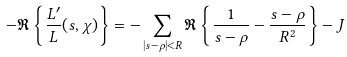Convert formula to latex. <formula><loc_0><loc_0><loc_500><loc_500>- \Re \left \{ \frac { L ^ { \prime } } { L } ( s , \chi ) \right \} = - \sum _ { | s - \rho | < R } \Re \left \{ \frac { 1 } { s - \rho } - \frac { s - \rho } { R ^ { 2 } } \right \} - J</formula> 